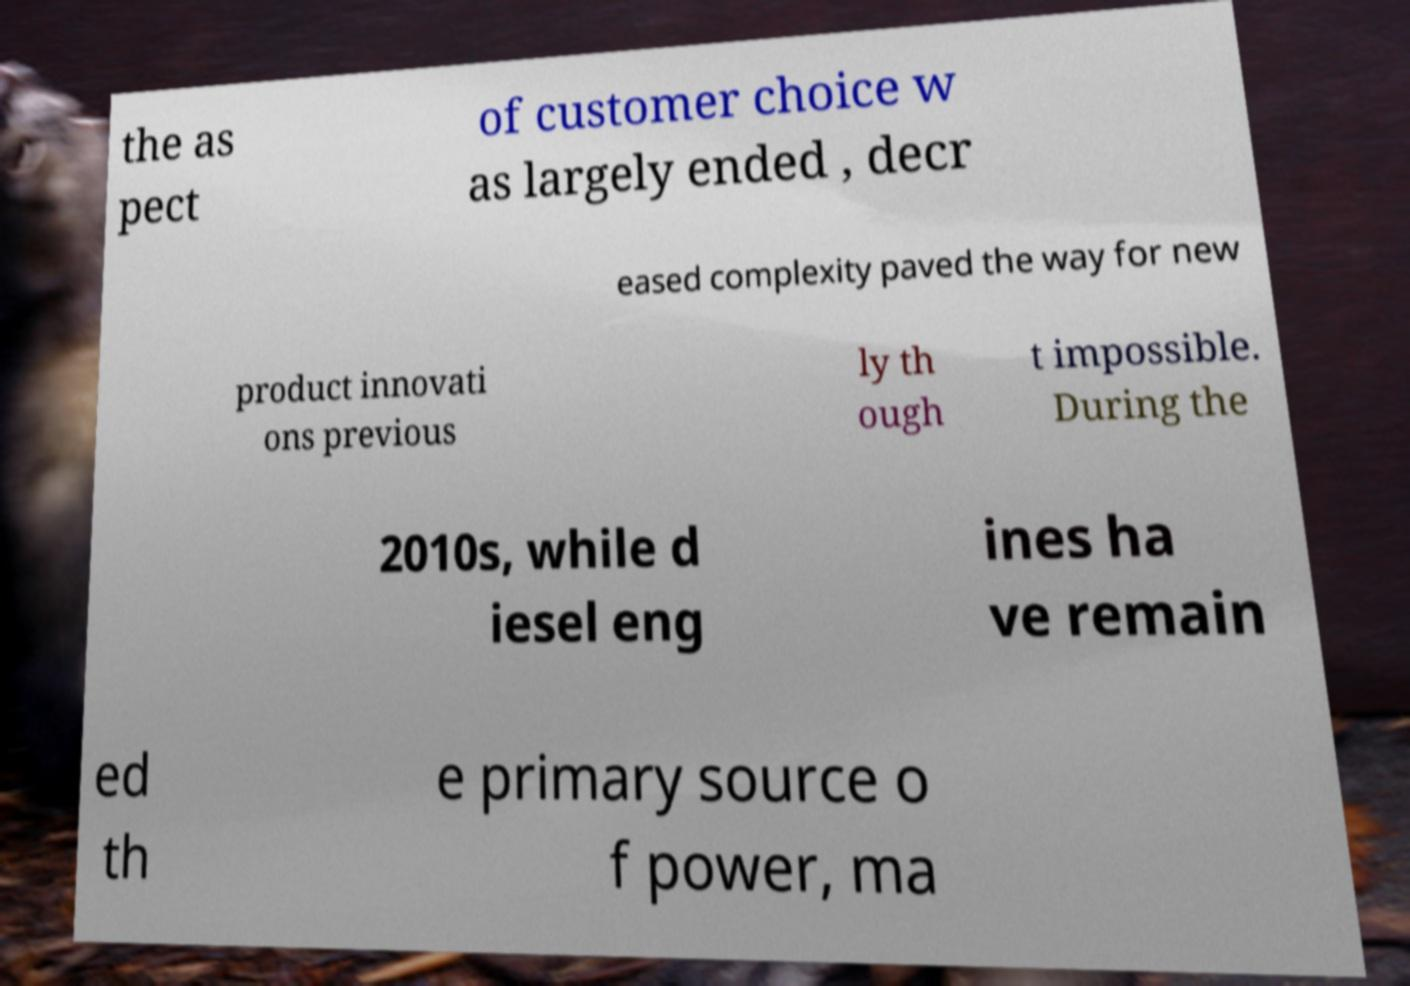Can you read and provide the text displayed in the image?This photo seems to have some interesting text. Can you extract and type it out for me? the as pect of customer choice w as largely ended , decr eased complexity paved the way for new product innovati ons previous ly th ough t impossible. During the 2010s, while d iesel eng ines ha ve remain ed th e primary source o f power, ma 